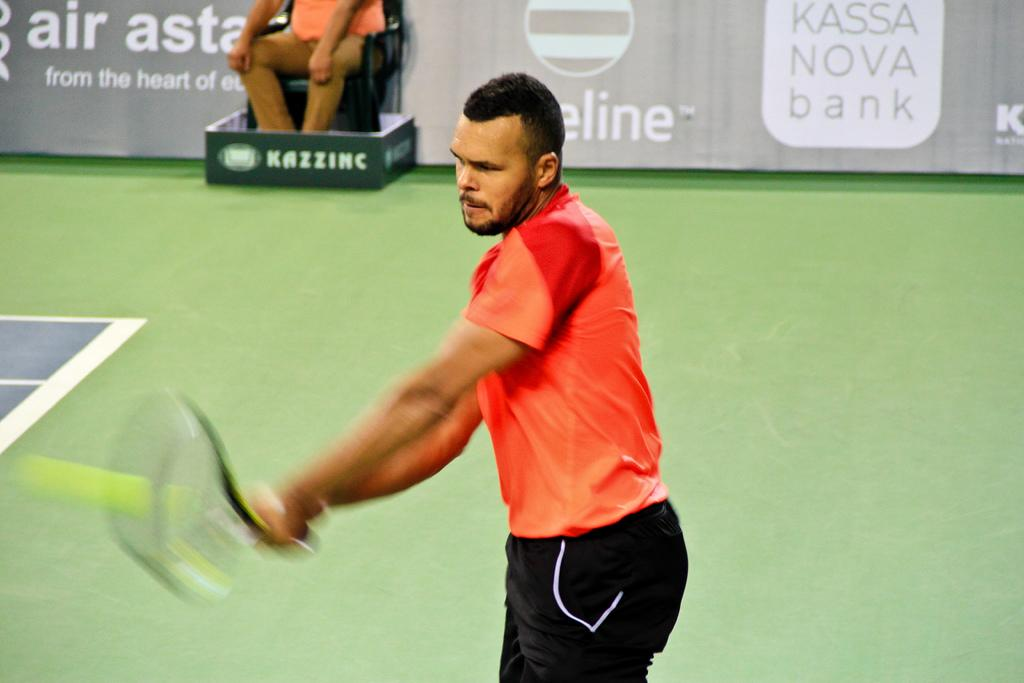What is the main subject of the image? There is a man standing in the center of the image. What is the man in the center holding? The man is holding a racket. Can you describe the background of the image? There is a man sitting in the background of the image, and there is a board visible as well. How many women are present in the image? There are no women present in the image. 